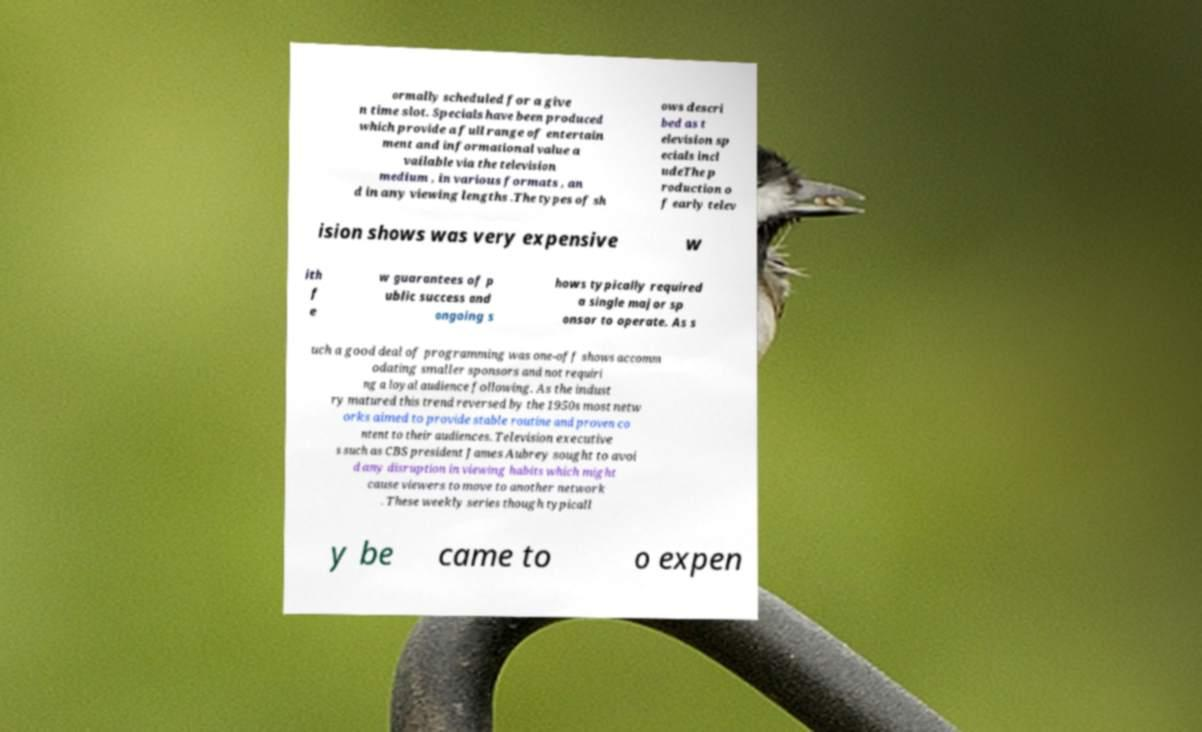Can you read and provide the text displayed in the image?This photo seems to have some interesting text. Can you extract and type it out for me? ormally scheduled for a give n time slot. Specials have been produced which provide a full range of entertain ment and informational value a vailable via the television medium , in various formats , an d in any viewing lengths .The types of sh ows descri bed as t elevision sp ecials incl udeThe p roduction o f early telev ision shows was very expensive w ith f e w guarantees of p ublic success and ongoing s hows typically required a single major sp onsor to operate. As s uch a good deal of programming was one-off shows accomm odating smaller sponsors and not requiri ng a loyal audience following. As the indust ry matured this trend reversed by the 1950s most netw orks aimed to provide stable routine and proven co ntent to their audiences. Television executive s such as CBS president James Aubrey sought to avoi d any disruption in viewing habits which might cause viewers to move to another network . These weekly series though typicall y be came to o expen 